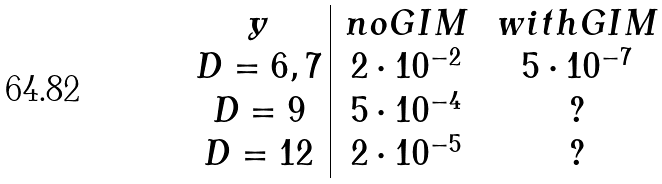Convert formula to latex. <formula><loc_0><loc_0><loc_500><loc_500>\begin{array} { c | c c } y & \, n o G I M \, & \, w i t h G I M \, \\ D = 6 , 7 & 2 \cdot 1 0 ^ { - 2 } & 5 \cdot 1 0 ^ { - 7 } \\ D = 9 & 5 \cdot 1 0 ^ { - 4 } & ? \\ D = 1 2 & 2 \cdot 1 0 ^ { - 5 } & ? \\ \end{array}</formula> 